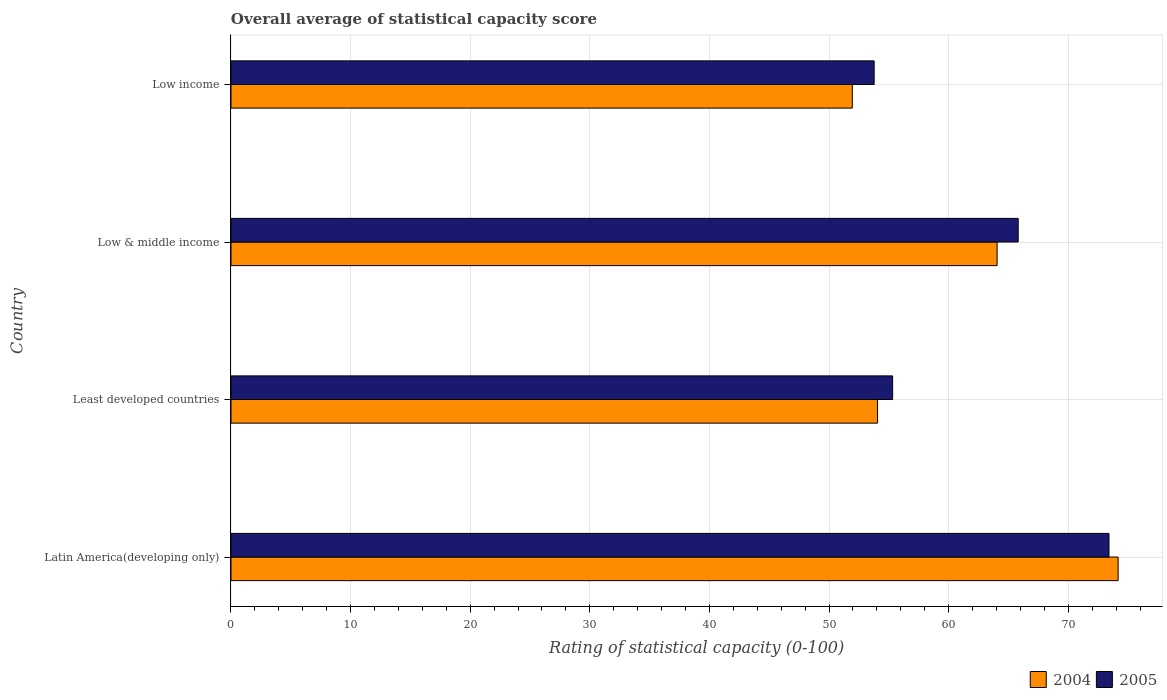How many groups of bars are there?
Make the answer very short. 4. Are the number of bars per tick equal to the number of legend labels?
Offer a very short reply. Yes. How many bars are there on the 2nd tick from the top?
Offer a very short reply. 2. What is the rating of statistical capacity in 2004 in Least developed countries?
Give a very brief answer. 54.05. Across all countries, what is the maximum rating of statistical capacity in 2005?
Make the answer very short. 73.4. Across all countries, what is the minimum rating of statistical capacity in 2005?
Offer a terse response. 53.77. In which country was the rating of statistical capacity in 2004 maximum?
Provide a succinct answer. Latin America(developing only). What is the total rating of statistical capacity in 2005 in the graph?
Give a very brief answer. 248.3. What is the difference between the rating of statistical capacity in 2004 in Least developed countries and that in Low & middle income?
Your response must be concise. -10. What is the difference between the rating of statistical capacity in 2004 in Low income and the rating of statistical capacity in 2005 in Low & middle income?
Provide a succinct answer. -13.87. What is the average rating of statistical capacity in 2005 per country?
Give a very brief answer. 62.07. What is the difference between the rating of statistical capacity in 2004 and rating of statistical capacity in 2005 in Low & middle income?
Keep it short and to the point. -1.76. In how many countries, is the rating of statistical capacity in 2004 greater than 36 ?
Your response must be concise. 4. What is the ratio of the rating of statistical capacity in 2005 in Latin America(developing only) to that in Least developed countries?
Provide a short and direct response. 1.33. Is the difference between the rating of statistical capacity in 2004 in Latin America(developing only) and Least developed countries greater than the difference between the rating of statistical capacity in 2005 in Latin America(developing only) and Least developed countries?
Your answer should be very brief. Yes. What is the difference between the highest and the second highest rating of statistical capacity in 2005?
Offer a terse response. 7.59. What is the difference between the highest and the lowest rating of statistical capacity in 2004?
Offer a very short reply. 22.22. In how many countries, is the rating of statistical capacity in 2004 greater than the average rating of statistical capacity in 2004 taken over all countries?
Give a very brief answer. 2. How many bars are there?
Provide a succinct answer. 8. Are the values on the major ticks of X-axis written in scientific E-notation?
Your answer should be very brief. No. Where does the legend appear in the graph?
Your answer should be compact. Bottom right. How many legend labels are there?
Provide a short and direct response. 2. How are the legend labels stacked?
Provide a short and direct response. Horizontal. What is the title of the graph?
Your answer should be compact. Overall average of statistical capacity score. Does "1975" appear as one of the legend labels in the graph?
Offer a very short reply. No. What is the label or title of the X-axis?
Ensure brevity in your answer.  Rating of statistical capacity (0-100). What is the label or title of the Y-axis?
Make the answer very short. Country. What is the Rating of statistical capacity (0-100) in 2004 in Latin America(developing only)?
Make the answer very short. 74.17. What is the Rating of statistical capacity (0-100) in 2005 in Latin America(developing only)?
Ensure brevity in your answer.  73.4. What is the Rating of statistical capacity (0-100) in 2004 in Least developed countries?
Offer a very short reply. 54.05. What is the Rating of statistical capacity (0-100) in 2005 in Least developed countries?
Ensure brevity in your answer.  55.32. What is the Rating of statistical capacity (0-100) of 2004 in Low & middle income?
Offer a very short reply. 64.05. What is the Rating of statistical capacity (0-100) in 2005 in Low & middle income?
Offer a very short reply. 65.81. What is the Rating of statistical capacity (0-100) of 2004 in Low income?
Offer a very short reply. 51.94. What is the Rating of statistical capacity (0-100) in 2005 in Low income?
Make the answer very short. 53.77. Across all countries, what is the maximum Rating of statistical capacity (0-100) in 2004?
Your response must be concise. 74.17. Across all countries, what is the maximum Rating of statistical capacity (0-100) of 2005?
Keep it short and to the point. 73.4. Across all countries, what is the minimum Rating of statistical capacity (0-100) of 2004?
Offer a terse response. 51.94. Across all countries, what is the minimum Rating of statistical capacity (0-100) of 2005?
Give a very brief answer. 53.77. What is the total Rating of statistical capacity (0-100) of 2004 in the graph?
Provide a short and direct response. 244.21. What is the total Rating of statistical capacity (0-100) of 2005 in the graph?
Offer a very short reply. 248.3. What is the difference between the Rating of statistical capacity (0-100) of 2004 in Latin America(developing only) and that in Least developed countries?
Your answer should be compact. 20.11. What is the difference between the Rating of statistical capacity (0-100) in 2005 in Latin America(developing only) and that in Least developed countries?
Offer a very short reply. 18.09. What is the difference between the Rating of statistical capacity (0-100) in 2004 in Latin America(developing only) and that in Low & middle income?
Your answer should be compact. 10.12. What is the difference between the Rating of statistical capacity (0-100) in 2005 in Latin America(developing only) and that in Low & middle income?
Offer a terse response. 7.59. What is the difference between the Rating of statistical capacity (0-100) in 2004 in Latin America(developing only) and that in Low income?
Provide a short and direct response. 22.22. What is the difference between the Rating of statistical capacity (0-100) in 2005 in Latin America(developing only) and that in Low income?
Provide a succinct answer. 19.63. What is the difference between the Rating of statistical capacity (0-100) of 2004 in Least developed countries and that in Low & middle income?
Your answer should be very brief. -10. What is the difference between the Rating of statistical capacity (0-100) in 2005 in Least developed countries and that in Low & middle income?
Your response must be concise. -10.5. What is the difference between the Rating of statistical capacity (0-100) in 2004 in Least developed countries and that in Low income?
Offer a terse response. 2.11. What is the difference between the Rating of statistical capacity (0-100) of 2005 in Least developed countries and that in Low income?
Ensure brevity in your answer.  1.55. What is the difference between the Rating of statistical capacity (0-100) of 2004 in Low & middle income and that in Low income?
Your answer should be compact. 12.1. What is the difference between the Rating of statistical capacity (0-100) in 2005 in Low & middle income and that in Low income?
Provide a short and direct response. 12.04. What is the difference between the Rating of statistical capacity (0-100) in 2004 in Latin America(developing only) and the Rating of statistical capacity (0-100) in 2005 in Least developed countries?
Keep it short and to the point. 18.85. What is the difference between the Rating of statistical capacity (0-100) of 2004 in Latin America(developing only) and the Rating of statistical capacity (0-100) of 2005 in Low & middle income?
Your answer should be compact. 8.35. What is the difference between the Rating of statistical capacity (0-100) in 2004 in Latin America(developing only) and the Rating of statistical capacity (0-100) in 2005 in Low income?
Ensure brevity in your answer.  20.4. What is the difference between the Rating of statistical capacity (0-100) in 2004 in Least developed countries and the Rating of statistical capacity (0-100) in 2005 in Low & middle income?
Keep it short and to the point. -11.76. What is the difference between the Rating of statistical capacity (0-100) in 2004 in Least developed countries and the Rating of statistical capacity (0-100) in 2005 in Low income?
Your response must be concise. 0.28. What is the difference between the Rating of statistical capacity (0-100) in 2004 in Low & middle income and the Rating of statistical capacity (0-100) in 2005 in Low income?
Your answer should be compact. 10.28. What is the average Rating of statistical capacity (0-100) in 2004 per country?
Offer a terse response. 61.05. What is the average Rating of statistical capacity (0-100) of 2005 per country?
Your response must be concise. 62.08. What is the difference between the Rating of statistical capacity (0-100) of 2004 and Rating of statistical capacity (0-100) of 2005 in Latin America(developing only)?
Keep it short and to the point. 0.76. What is the difference between the Rating of statistical capacity (0-100) of 2004 and Rating of statistical capacity (0-100) of 2005 in Least developed countries?
Give a very brief answer. -1.26. What is the difference between the Rating of statistical capacity (0-100) in 2004 and Rating of statistical capacity (0-100) in 2005 in Low & middle income?
Your answer should be compact. -1.76. What is the difference between the Rating of statistical capacity (0-100) of 2004 and Rating of statistical capacity (0-100) of 2005 in Low income?
Your answer should be very brief. -1.83. What is the ratio of the Rating of statistical capacity (0-100) in 2004 in Latin America(developing only) to that in Least developed countries?
Offer a very short reply. 1.37. What is the ratio of the Rating of statistical capacity (0-100) in 2005 in Latin America(developing only) to that in Least developed countries?
Ensure brevity in your answer.  1.33. What is the ratio of the Rating of statistical capacity (0-100) in 2004 in Latin America(developing only) to that in Low & middle income?
Ensure brevity in your answer.  1.16. What is the ratio of the Rating of statistical capacity (0-100) in 2005 in Latin America(developing only) to that in Low & middle income?
Make the answer very short. 1.12. What is the ratio of the Rating of statistical capacity (0-100) in 2004 in Latin America(developing only) to that in Low income?
Offer a very short reply. 1.43. What is the ratio of the Rating of statistical capacity (0-100) in 2005 in Latin America(developing only) to that in Low income?
Make the answer very short. 1.37. What is the ratio of the Rating of statistical capacity (0-100) of 2004 in Least developed countries to that in Low & middle income?
Provide a short and direct response. 0.84. What is the ratio of the Rating of statistical capacity (0-100) in 2005 in Least developed countries to that in Low & middle income?
Provide a succinct answer. 0.84. What is the ratio of the Rating of statistical capacity (0-100) in 2004 in Least developed countries to that in Low income?
Offer a very short reply. 1.04. What is the ratio of the Rating of statistical capacity (0-100) in 2005 in Least developed countries to that in Low income?
Provide a short and direct response. 1.03. What is the ratio of the Rating of statistical capacity (0-100) in 2004 in Low & middle income to that in Low income?
Your response must be concise. 1.23. What is the ratio of the Rating of statistical capacity (0-100) in 2005 in Low & middle income to that in Low income?
Offer a terse response. 1.22. What is the difference between the highest and the second highest Rating of statistical capacity (0-100) of 2004?
Offer a terse response. 10.12. What is the difference between the highest and the second highest Rating of statistical capacity (0-100) in 2005?
Your answer should be compact. 7.59. What is the difference between the highest and the lowest Rating of statistical capacity (0-100) in 2004?
Make the answer very short. 22.22. What is the difference between the highest and the lowest Rating of statistical capacity (0-100) in 2005?
Provide a short and direct response. 19.63. 